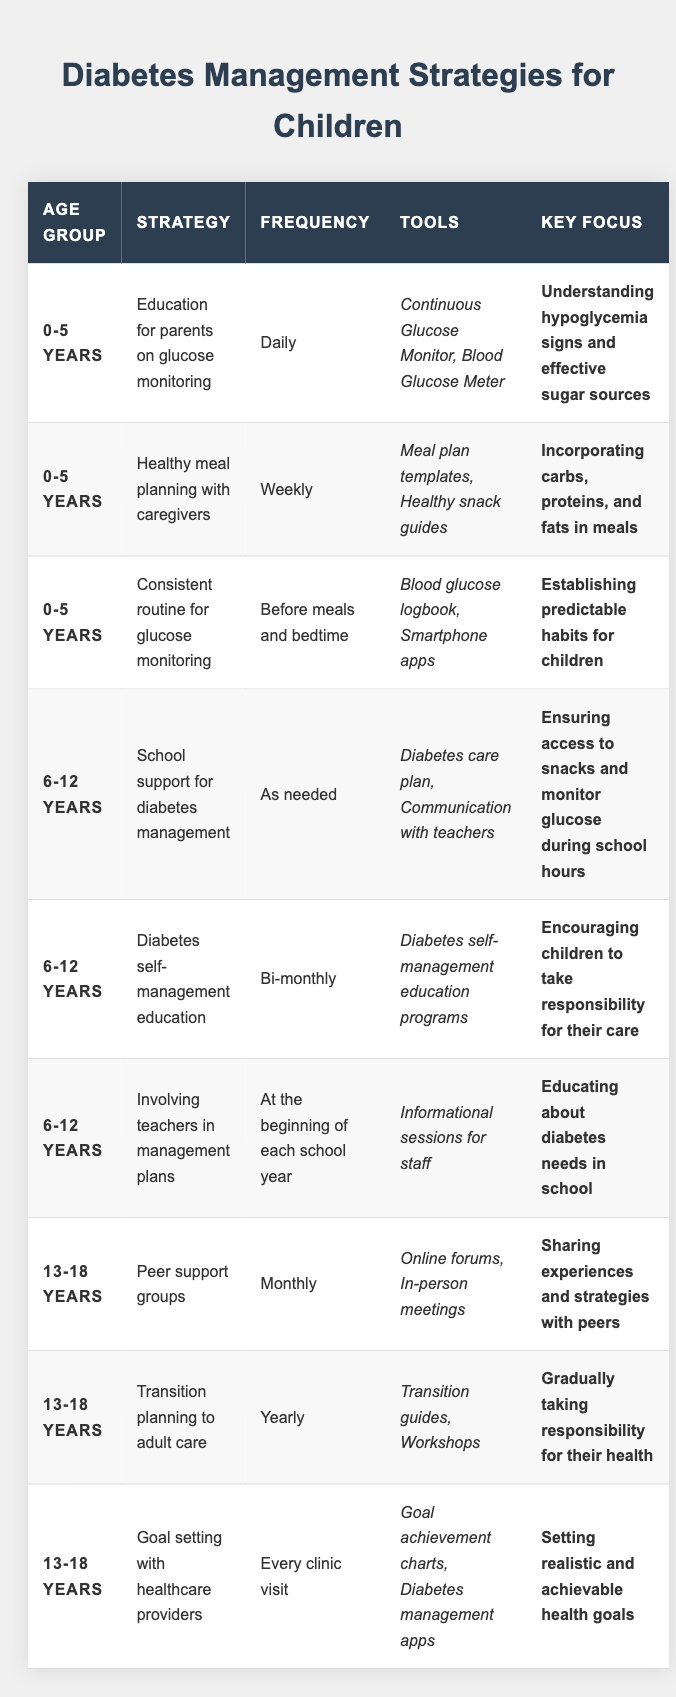What management strategy is recommended for the 6-12 years age group regarding diabetes self-management education? The table shows that for the 6-12 years age group, the strategy is "Diabetes self-management education," with a frequency of bi-monthly.
Answer: Diabetes self-management education Which age group has the highest frequency of glucose monitoring strategies? The table lists glucose monitoring strategies for the 0-5 years age group with a frequency of daily, which is the highest compared to others.
Answer: 0-5 years Is there a strategy focused on involving teachers in diabetes management plans for children? Yes, the table states that for the 6-12 years age group, there is a strategy called "Involving teachers in management plans" at the beginning of each school year.
Answer: Yes For children aged 13-18 years, how often do they participate in peer support groups? According to the table, children aged 13-18 years participate in peer support groups monthly.
Answer: Monthly How many different strategies are listed for the 0-5 years age group? The table shows three strategies for the 0-5 years age group: education for parents, healthy meal planning, and consistent routine for glucose monitoring. Therefore, the total is three.
Answer: 3 What is the key focus of the strategy for school support in diabetes management for the 6-12 years age group? The table indicates that the key focus of this strategy is ensuring access to snacks and monitoring glucose during school hours for the 6-12 years age group.
Answer: Ensuring access to snacks and monitoring glucose Compare the frequency of diabetes self-management education between age groups 6-12 years and 13-18 years. The 6-12 years age group has diabetes self-management education with a frequency of bi-monthly, while the 13-18 years age group does not have a specific self-management education frequency listed in the table. Thus, they differ in frequency.
Answer: Different frequencies What tools are suggested for parents in the glucose monitoring education strategy for children aged 0-5? The table lists "Continuous Glucose Monitor" and "Blood Glucose Meter" as tools recommended for parents in the glucose monitoring education strategy for the 0-5 years age group.
Answer: Continuous Glucose Monitor, Blood Glucose Meter Are there any strategies listed for the 13-18 years age group that occur less frequently than annually? Yes, the strategy "Peer support groups" for the 13-18 years age group occurs monthly, which is less frequent than annually; thus, there are strategies that are less frequent than annually listed.
Answer: Yes What is the key focus of the goal-setting strategy for children aged 13-18 years? As per the table, the key focus of the goal-setting strategy for the 13-18 years age group is setting realistic and achievable health goals.
Answer: Setting realistic and achievable health goals Which age group has strategies that include consistent routines for glucose monitoring? The table confirms that the 0-5 years age group has the strategy for a consistent routine for glucose monitoring.
Answer: 0-5 years 